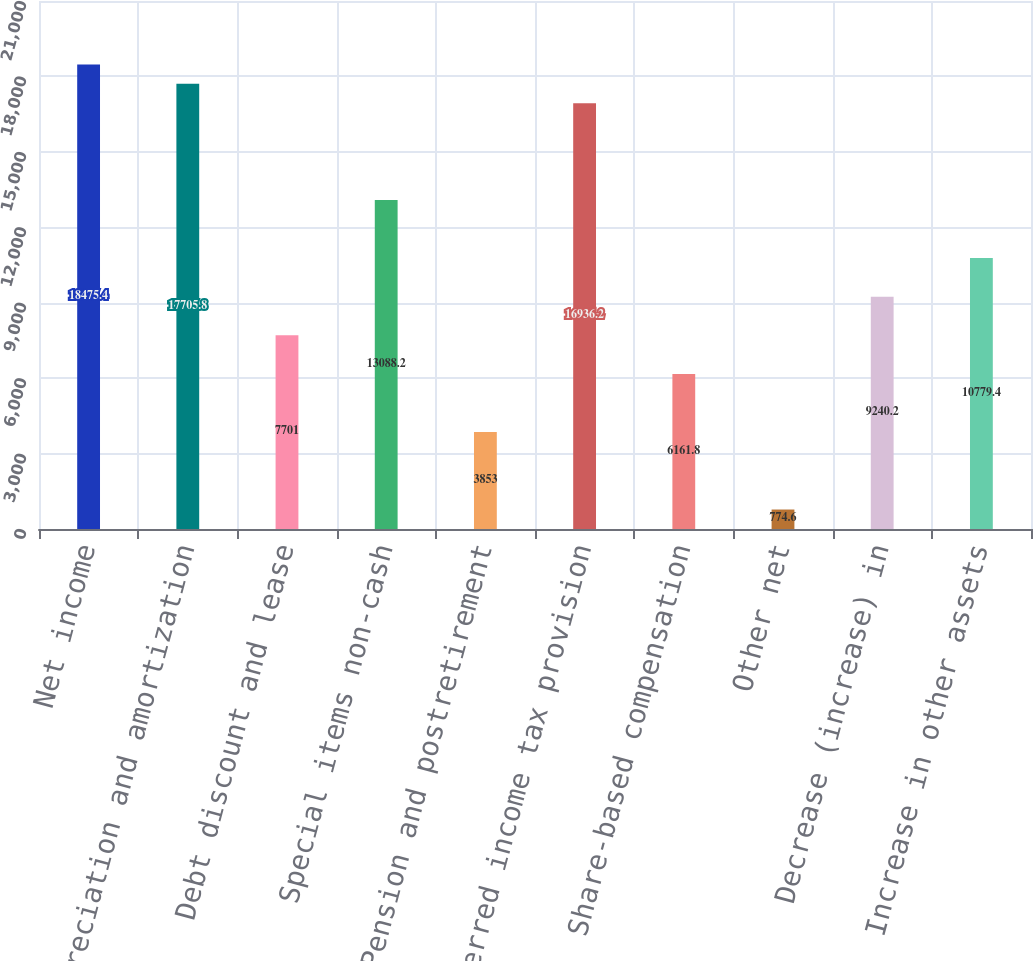<chart> <loc_0><loc_0><loc_500><loc_500><bar_chart><fcel>Net income<fcel>Depreciation and amortization<fcel>Debt discount and lease<fcel>Special items non-cash<fcel>Pension and postretirement<fcel>Deferred income tax provision<fcel>Share-based compensation<fcel>Other net<fcel>Decrease (increase) in<fcel>Increase in other assets<nl><fcel>18475.4<fcel>17705.8<fcel>7701<fcel>13088.2<fcel>3853<fcel>16936.2<fcel>6161.8<fcel>774.6<fcel>9240.2<fcel>10779.4<nl></chart> 